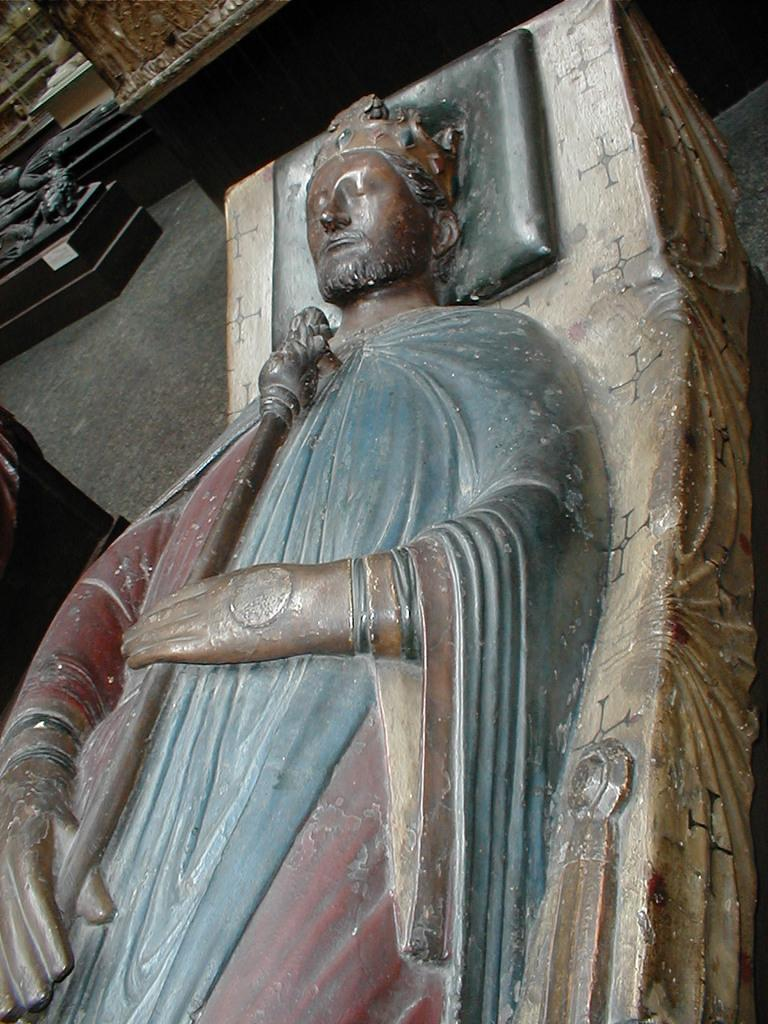What is the main subject of the image? There is a sculpture in the image. Can you describe the sculpture? Unfortunately, the provided facts do not include a description of the sculpture. Are there any other sculptures visible in the image? Yes, there are additional sculptures visible in the background of the image. What type of pie is being held under the umbrella in the image? There is no pie or umbrella present in the image; it features a sculpture and additional sculptures in the background. 